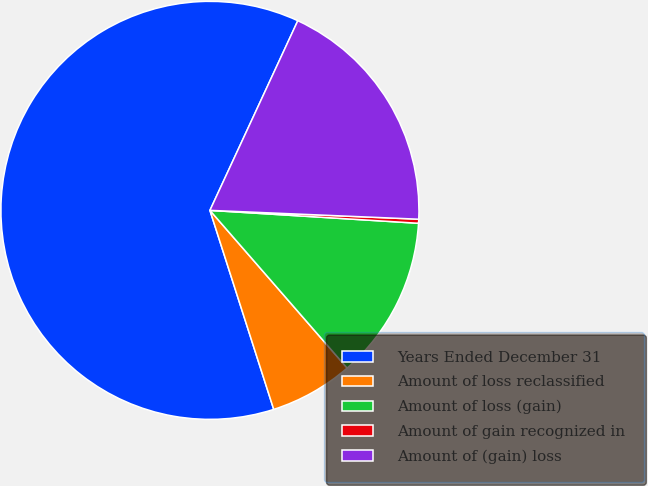<chart> <loc_0><loc_0><loc_500><loc_500><pie_chart><fcel>Years Ended December 31<fcel>Amount of loss reclassified<fcel>Amount of loss (gain)<fcel>Amount of gain recognized in<fcel>Amount of (gain) loss<nl><fcel>61.85%<fcel>6.46%<fcel>12.62%<fcel>0.31%<fcel>18.77%<nl></chart> 